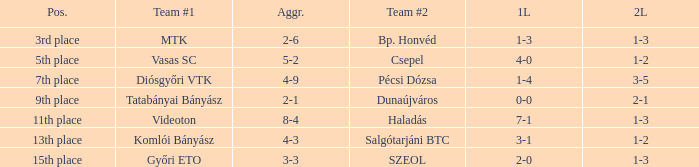What is the team #1 with an 11th place position? Videoton. 